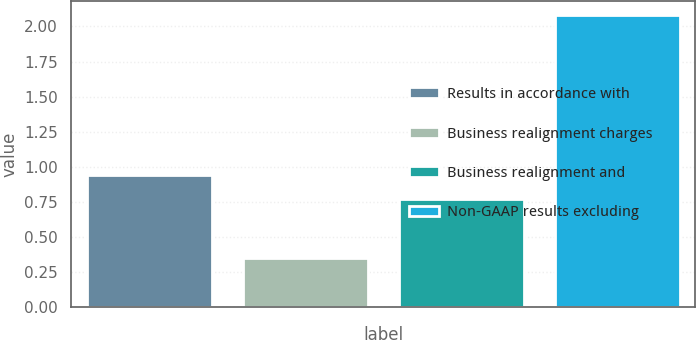<chart> <loc_0><loc_0><loc_500><loc_500><bar_chart><fcel>Results in accordance with<fcel>Business realignment charges<fcel>Business realignment and<fcel>Non-GAAP results excluding<nl><fcel>0.94<fcel>0.35<fcel>0.77<fcel>2.08<nl></chart> 